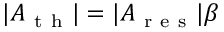<formula> <loc_0><loc_0><loc_500><loc_500>| A _ { t h } | = | A _ { r e s } | \beta</formula> 